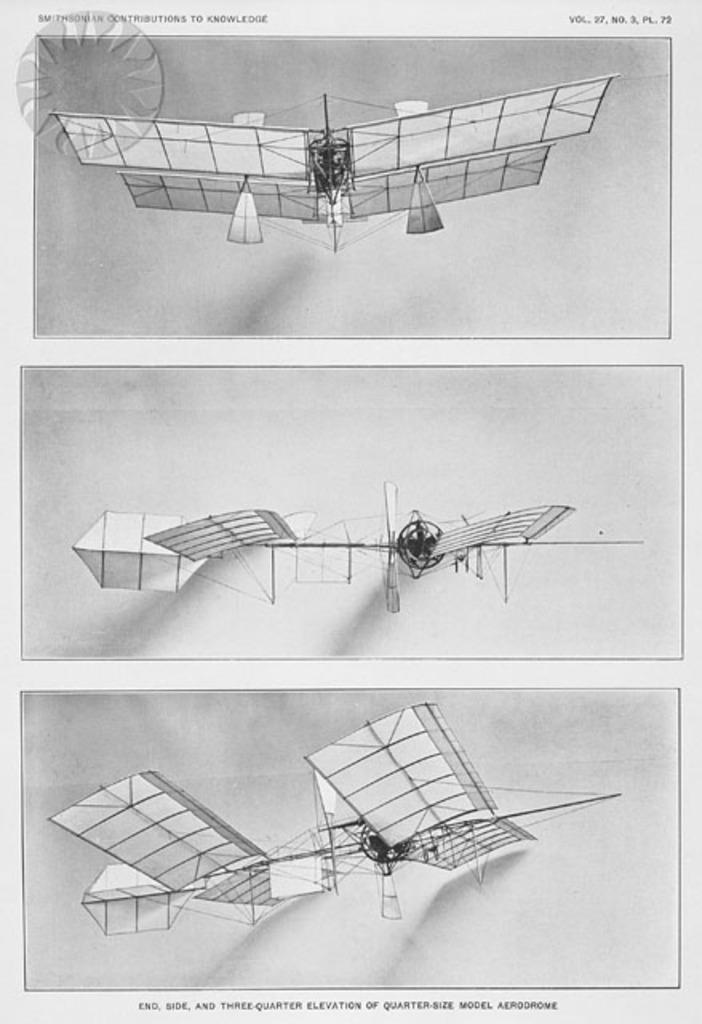<image>
Relay a brief, clear account of the picture shown. An exhibit of an early airplane design is seen in three photos on a Smithsonian handout. 